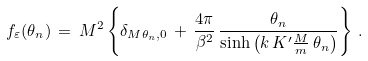Convert formula to latex. <formula><loc_0><loc_0><loc_500><loc_500>f _ { \varepsilon } ( \theta _ { n } ) \, = \, M ^ { 2 } \left \{ \delta _ { M \theta _ { n } , 0 } \, + \, \frac { 4 \pi } { \beta ^ { 2 } } \, \frac { \theta _ { n } } { \sinh \left ( k \, K ^ { \prime } \frac { M } { m } \, \theta _ { n } \right ) } \right \} \, .</formula> 